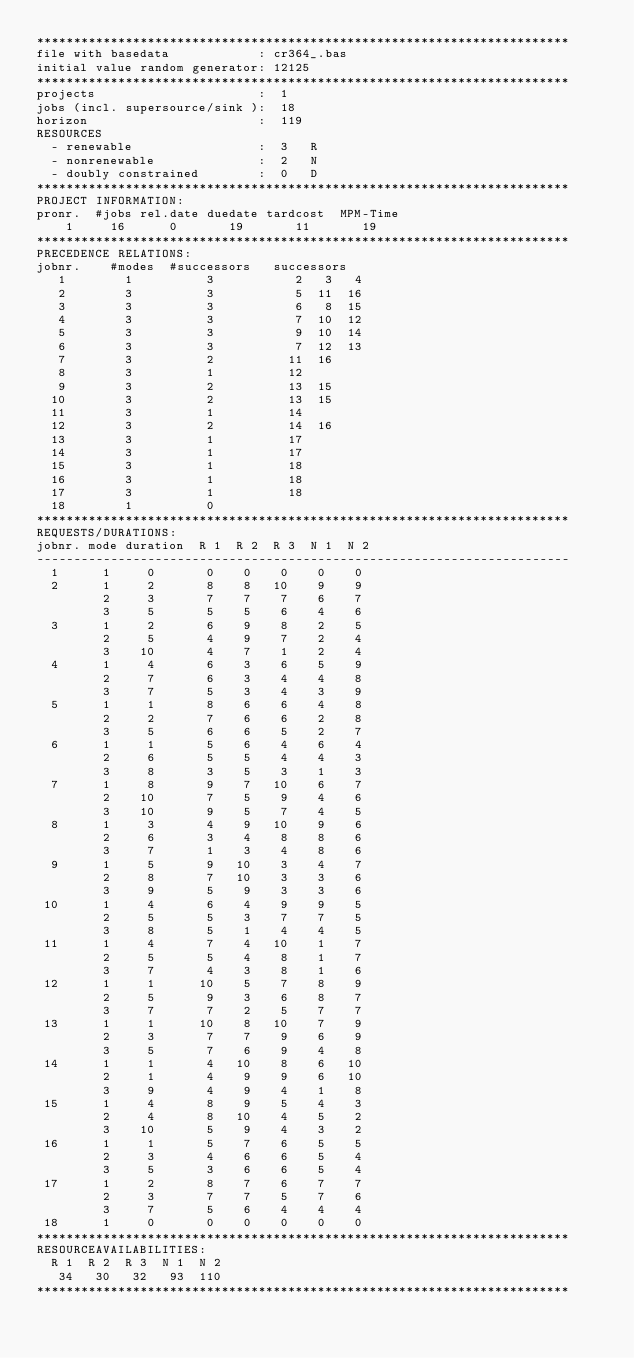Convert code to text. <code><loc_0><loc_0><loc_500><loc_500><_ObjectiveC_>************************************************************************
file with basedata            : cr364_.bas
initial value random generator: 12125
************************************************************************
projects                      :  1
jobs (incl. supersource/sink ):  18
horizon                       :  119
RESOURCES
  - renewable                 :  3   R
  - nonrenewable              :  2   N
  - doubly constrained        :  0   D
************************************************************************
PROJECT INFORMATION:
pronr.  #jobs rel.date duedate tardcost  MPM-Time
    1     16      0       19       11       19
************************************************************************
PRECEDENCE RELATIONS:
jobnr.    #modes  #successors   successors
   1        1          3           2   3   4
   2        3          3           5  11  16
   3        3          3           6   8  15
   4        3          3           7  10  12
   5        3          3           9  10  14
   6        3          3           7  12  13
   7        3          2          11  16
   8        3          1          12
   9        3          2          13  15
  10        3          2          13  15
  11        3          1          14
  12        3          2          14  16
  13        3          1          17
  14        3          1          17
  15        3          1          18
  16        3          1          18
  17        3          1          18
  18        1          0        
************************************************************************
REQUESTS/DURATIONS:
jobnr. mode duration  R 1  R 2  R 3  N 1  N 2
------------------------------------------------------------------------
  1      1     0       0    0    0    0    0
  2      1     2       8    8   10    9    9
         2     3       7    7    7    6    7
         3     5       5    5    6    4    6
  3      1     2       6    9    8    2    5
         2     5       4    9    7    2    4
         3    10       4    7    1    2    4
  4      1     4       6    3    6    5    9
         2     7       6    3    4    4    8
         3     7       5    3    4    3    9
  5      1     1       8    6    6    4    8
         2     2       7    6    6    2    8
         3     5       6    6    5    2    7
  6      1     1       5    6    4    6    4
         2     6       5    5    4    4    3
         3     8       3    5    3    1    3
  7      1     8       9    7   10    6    7
         2    10       7    5    9    4    6
         3    10       9    5    7    4    5
  8      1     3       4    9   10    9    6
         2     6       3    4    8    8    6
         3     7       1    3    4    8    6
  9      1     5       9   10    3    4    7
         2     8       7   10    3    3    6
         3     9       5    9    3    3    6
 10      1     4       6    4    9    9    5
         2     5       5    3    7    7    5
         3     8       5    1    4    4    5
 11      1     4       7    4   10    1    7
         2     5       5    4    8    1    7
         3     7       4    3    8    1    6
 12      1     1      10    5    7    8    9
         2     5       9    3    6    8    7
         3     7       7    2    5    7    7
 13      1     1      10    8   10    7    9
         2     3       7    7    9    6    9
         3     5       7    6    9    4    8
 14      1     1       4   10    8    6   10
         2     1       4    9    9    6   10
         3     9       4    9    4    1    8
 15      1     4       8    9    5    4    3
         2     4       8   10    4    5    2
         3    10       5    9    4    3    2
 16      1     1       5    7    6    5    5
         2     3       4    6    6    5    4
         3     5       3    6    6    5    4
 17      1     2       8    7    6    7    7
         2     3       7    7    5    7    6
         3     7       5    6    4    4    4
 18      1     0       0    0    0    0    0
************************************************************************
RESOURCEAVAILABILITIES:
  R 1  R 2  R 3  N 1  N 2
   34   30   32   93  110
************************************************************************
</code> 